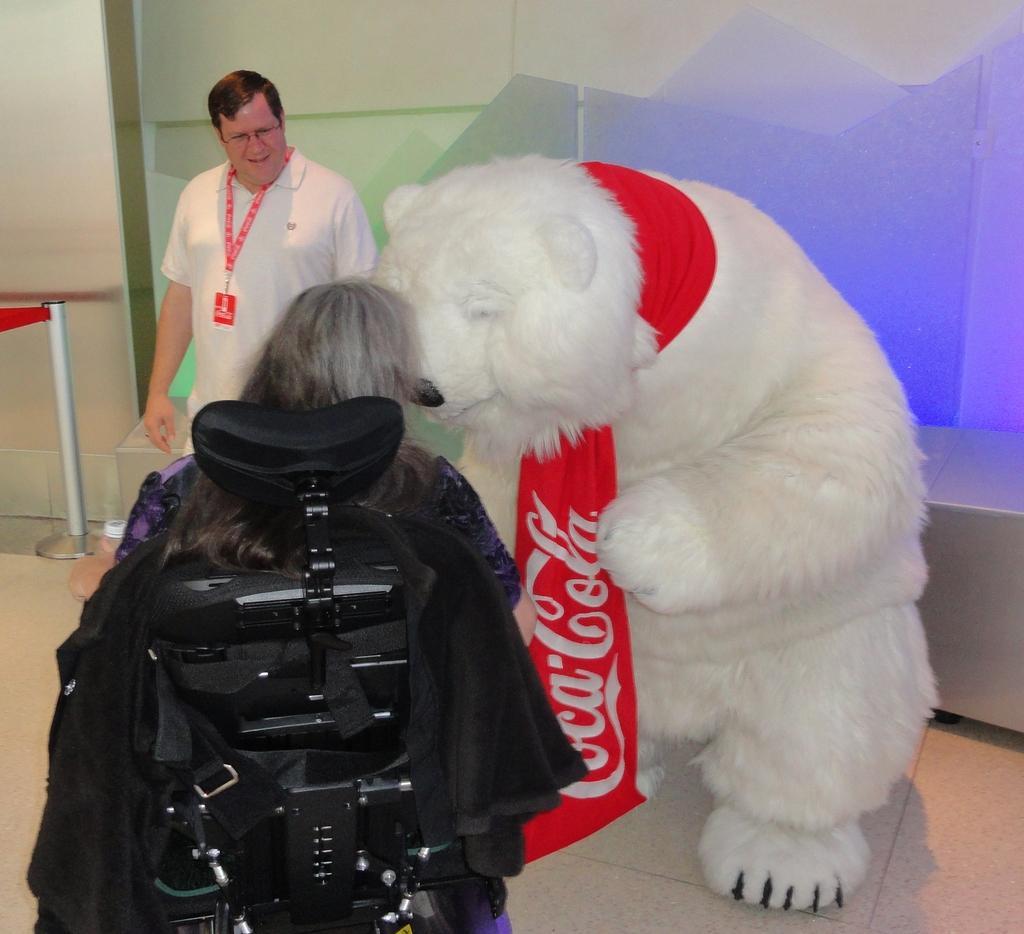Describe this image in one or two sentences. In this image in front there is a person sitting on the wheelchair. Beside her there is a bear. In front of her there is a person. On the left side of the image there is a metal fence. At the bottom of the image there is a floor. In the background of the image there is a wall. 